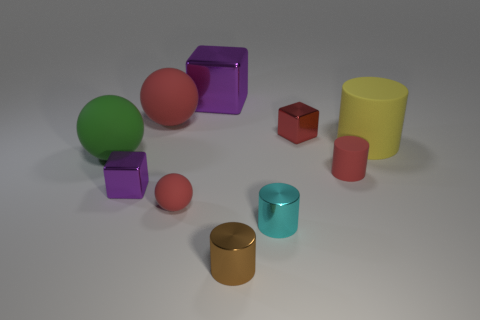Subtract all cylinders. How many objects are left? 6 Subtract all tiny purple metallic cylinders. Subtract all tiny cyan cylinders. How many objects are left? 9 Add 4 big metallic things. How many big metallic things are left? 5 Add 4 large blue spheres. How many large blue spheres exist? 4 Subtract 0 gray cubes. How many objects are left? 10 